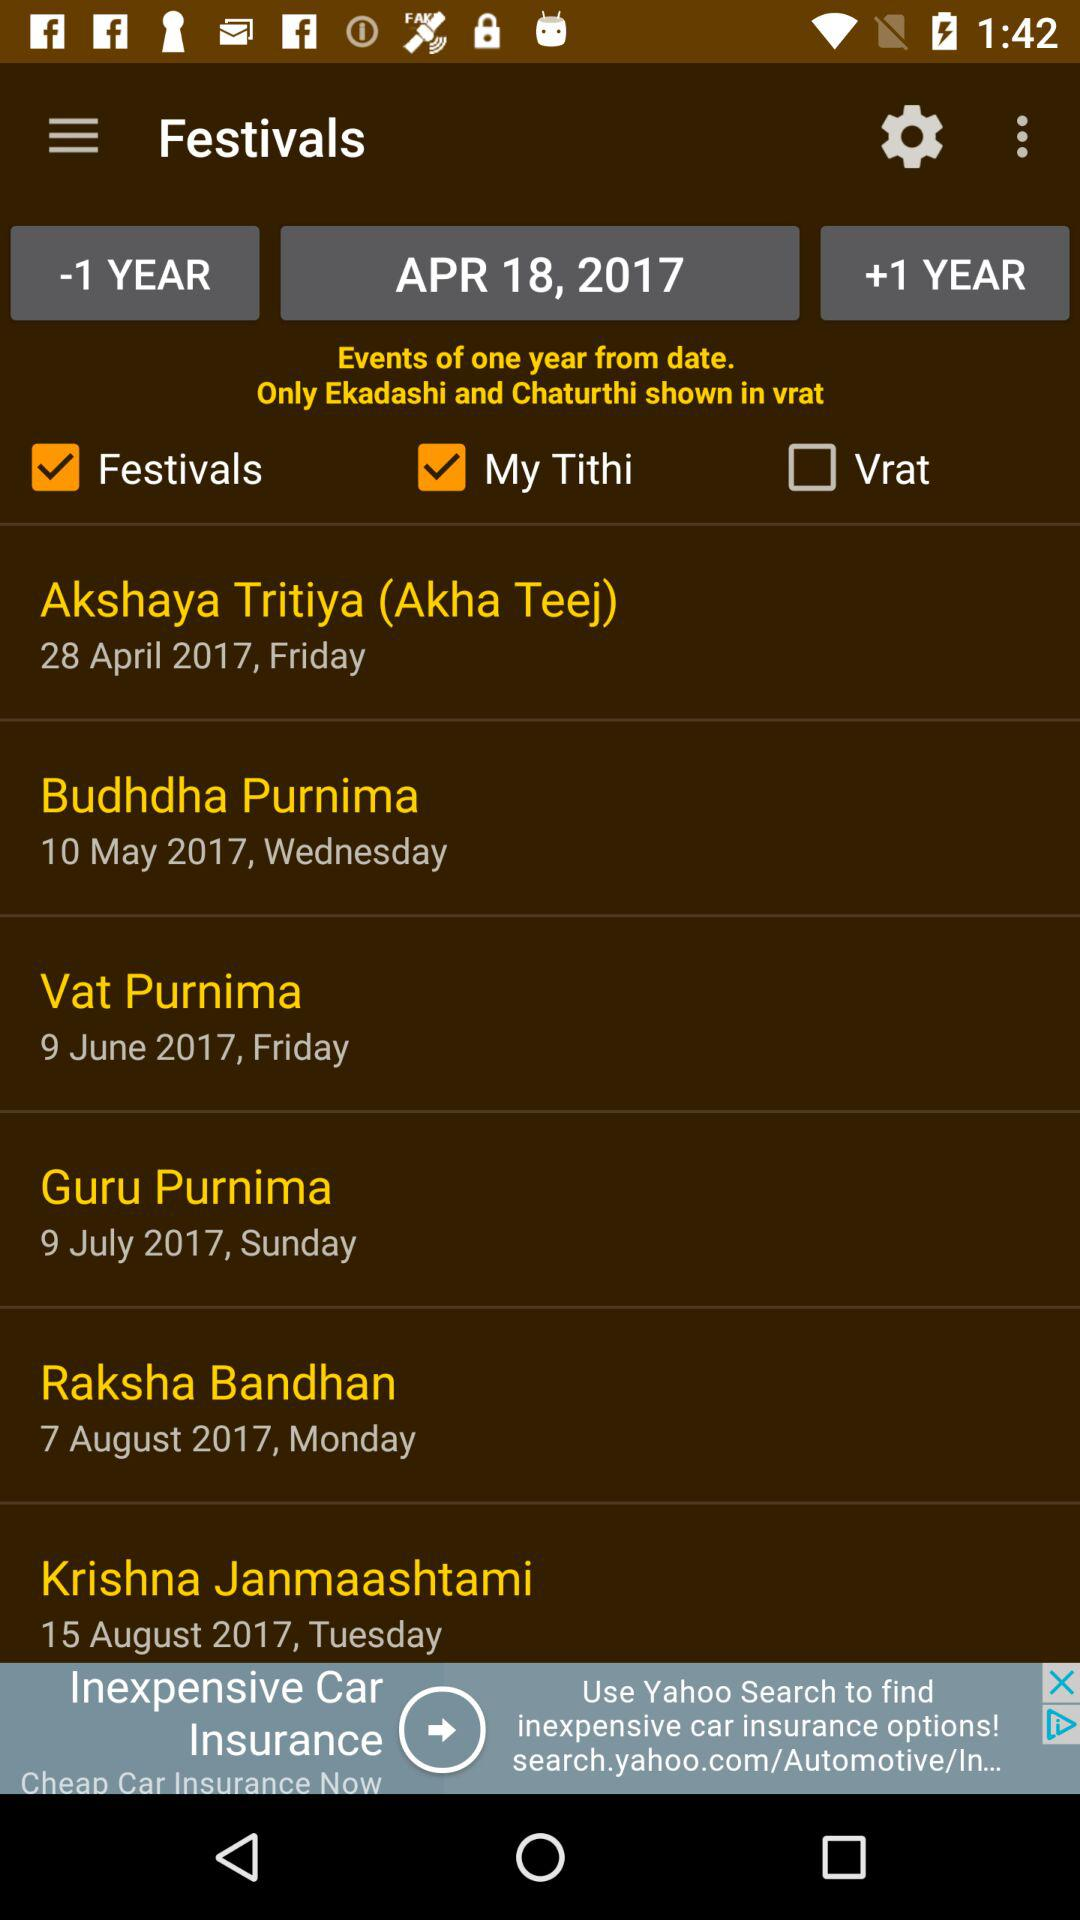What is the date of "Akshaya Tritiya"? The date of "Akshaya Tritiya" is Friday, April 28, 2017. 